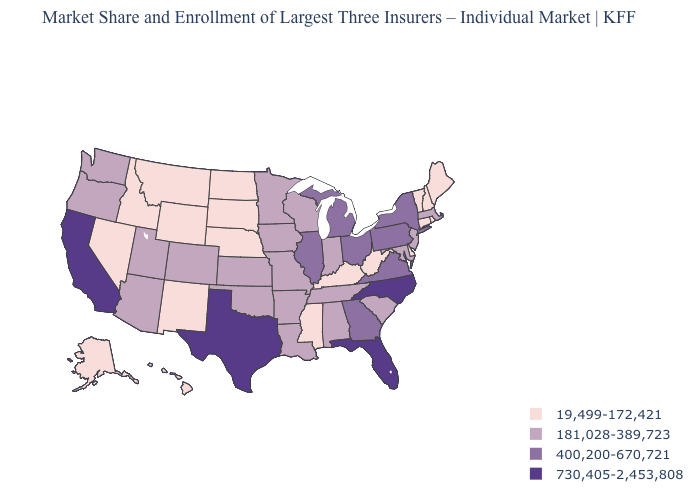Does Alabama have the same value as Arizona?
Keep it brief. Yes. What is the value of Kansas?
Keep it brief. 181,028-389,723. Name the states that have a value in the range 400,200-670,721?
Be succinct. Georgia, Illinois, Michigan, New York, Ohio, Pennsylvania, Virginia. Name the states that have a value in the range 400,200-670,721?
Keep it brief. Georgia, Illinois, Michigan, New York, Ohio, Pennsylvania, Virginia. Name the states that have a value in the range 19,499-172,421?
Keep it brief. Alaska, Connecticut, Delaware, Hawaii, Idaho, Kentucky, Maine, Mississippi, Montana, Nebraska, Nevada, New Hampshire, New Mexico, North Dakota, Rhode Island, South Dakota, Vermont, West Virginia, Wyoming. Among the states that border South Dakota , does Montana have the lowest value?
Write a very short answer. Yes. Does the map have missing data?
Give a very brief answer. No. What is the highest value in the USA?
Concise answer only. 730,405-2,453,808. Name the states that have a value in the range 400,200-670,721?
Be succinct. Georgia, Illinois, Michigan, New York, Ohio, Pennsylvania, Virginia. Name the states that have a value in the range 400,200-670,721?
Write a very short answer. Georgia, Illinois, Michigan, New York, Ohio, Pennsylvania, Virginia. Name the states that have a value in the range 400,200-670,721?
Concise answer only. Georgia, Illinois, Michigan, New York, Ohio, Pennsylvania, Virginia. Does Texas have the lowest value in the USA?
Quick response, please. No. Does Iowa have the same value as South Dakota?
Answer briefly. No. What is the value of New Hampshire?
Concise answer only. 19,499-172,421. Which states have the lowest value in the USA?
Concise answer only. Alaska, Connecticut, Delaware, Hawaii, Idaho, Kentucky, Maine, Mississippi, Montana, Nebraska, Nevada, New Hampshire, New Mexico, North Dakota, Rhode Island, South Dakota, Vermont, West Virginia, Wyoming. 